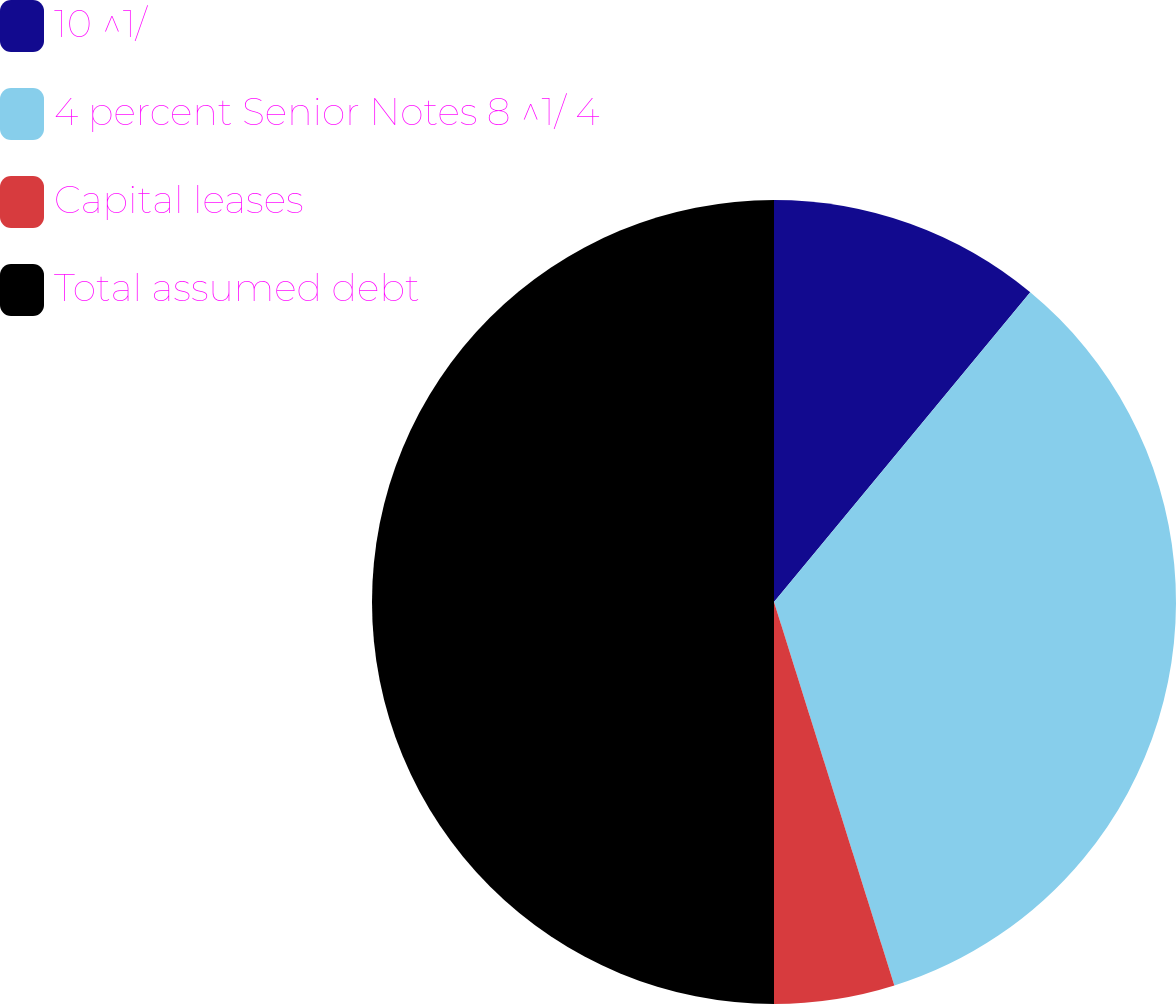Convert chart to OTSL. <chart><loc_0><loc_0><loc_500><loc_500><pie_chart><fcel>10 ^1/<fcel>4 percent Senior Notes 8 ^1/ 4<fcel>Capital leases<fcel>Total assumed debt<nl><fcel>11.0%<fcel>34.16%<fcel>4.84%<fcel>50.0%<nl></chart> 